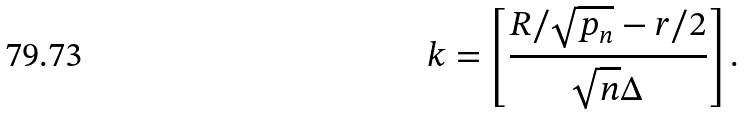<formula> <loc_0><loc_0><loc_500><loc_500>k = \left [ \frac { R / \sqrt { p _ { n } } - r / 2 } { \sqrt { n } \Delta } \right ] .</formula> 